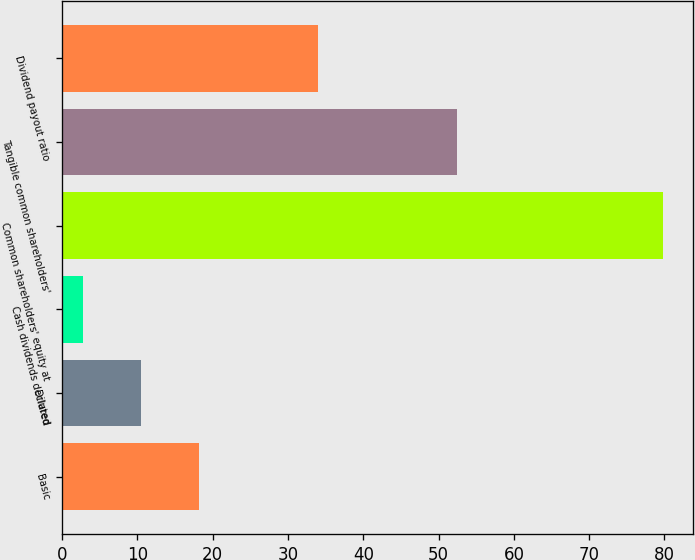Convert chart to OTSL. <chart><loc_0><loc_0><loc_500><loc_500><bar_chart><fcel>Basic<fcel>Diluted<fcel>Cash dividends declared<fcel>Common shareholders' equity at<fcel>Tangible common shareholders'<fcel>Dividend payout ratio<nl><fcel>18.2<fcel>10.5<fcel>2.8<fcel>79.81<fcel>52.45<fcel>33.94<nl></chart> 